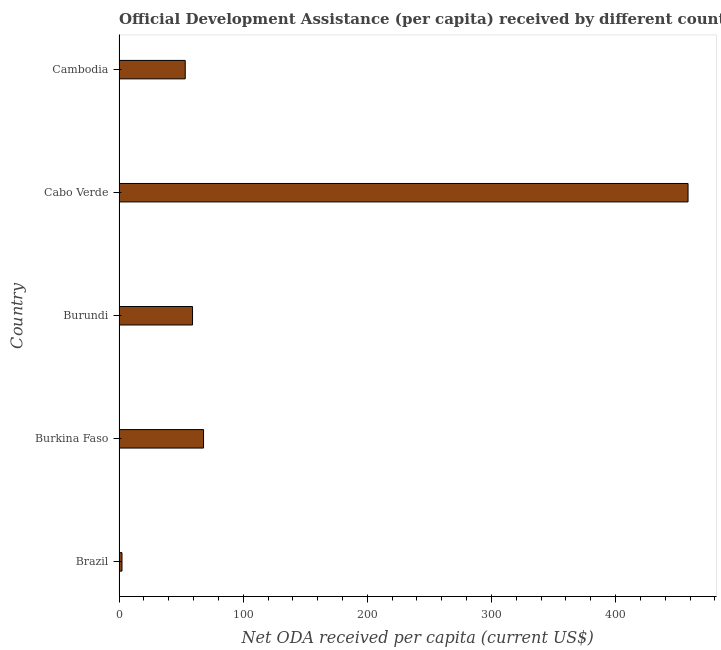What is the title of the graph?
Make the answer very short. Official Development Assistance (per capita) received by different countries in the year 2008. What is the label or title of the X-axis?
Offer a very short reply. Net ODA received per capita (current US$). What is the label or title of the Y-axis?
Ensure brevity in your answer.  Country. What is the net oda received per capita in Burkina Faso?
Your answer should be compact. 68.06. Across all countries, what is the maximum net oda received per capita?
Provide a succinct answer. 458.39. Across all countries, what is the minimum net oda received per capita?
Give a very brief answer. 2.36. In which country was the net oda received per capita maximum?
Your response must be concise. Cabo Verde. What is the sum of the net oda received per capita?
Ensure brevity in your answer.  641.33. What is the difference between the net oda received per capita in Brazil and Cambodia?
Your answer should be compact. -50.95. What is the average net oda received per capita per country?
Offer a very short reply. 128.27. What is the median net oda received per capita?
Provide a succinct answer. 59.2. In how many countries, is the net oda received per capita greater than 140 US$?
Offer a very short reply. 1. What is the ratio of the net oda received per capita in Brazil to that in Burundi?
Provide a succinct answer. 0.04. Is the net oda received per capita in Brazil less than that in Cabo Verde?
Give a very brief answer. Yes. What is the difference between the highest and the second highest net oda received per capita?
Provide a succinct answer. 390.32. Is the sum of the net oda received per capita in Burundi and Cabo Verde greater than the maximum net oda received per capita across all countries?
Keep it short and to the point. Yes. What is the difference between the highest and the lowest net oda received per capita?
Make the answer very short. 456.03. In how many countries, is the net oda received per capita greater than the average net oda received per capita taken over all countries?
Your response must be concise. 1. How many bars are there?
Your response must be concise. 5. How many countries are there in the graph?
Provide a succinct answer. 5. What is the Net ODA received per capita (current US$) of Brazil?
Make the answer very short. 2.36. What is the Net ODA received per capita (current US$) of Burkina Faso?
Your answer should be very brief. 68.06. What is the Net ODA received per capita (current US$) of Burundi?
Keep it short and to the point. 59.2. What is the Net ODA received per capita (current US$) of Cabo Verde?
Your answer should be very brief. 458.39. What is the Net ODA received per capita (current US$) of Cambodia?
Offer a terse response. 53.31. What is the difference between the Net ODA received per capita (current US$) in Brazil and Burkina Faso?
Provide a short and direct response. -65.7. What is the difference between the Net ODA received per capita (current US$) in Brazil and Burundi?
Your answer should be very brief. -56.84. What is the difference between the Net ODA received per capita (current US$) in Brazil and Cabo Verde?
Keep it short and to the point. -456.03. What is the difference between the Net ODA received per capita (current US$) in Brazil and Cambodia?
Offer a terse response. -50.95. What is the difference between the Net ODA received per capita (current US$) in Burkina Faso and Burundi?
Make the answer very short. 8.87. What is the difference between the Net ODA received per capita (current US$) in Burkina Faso and Cabo Verde?
Give a very brief answer. -390.33. What is the difference between the Net ODA received per capita (current US$) in Burkina Faso and Cambodia?
Offer a terse response. 14.75. What is the difference between the Net ODA received per capita (current US$) in Burundi and Cabo Verde?
Your answer should be very brief. -399.19. What is the difference between the Net ODA received per capita (current US$) in Burundi and Cambodia?
Make the answer very short. 5.89. What is the difference between the Net ODA received per capita (current US$) in Cabo Verde and Cambodia?
Ensure brevity in your answer.  405.08. What is the ratio of the Net ODA received per capita (current US$) in Brazil to that in Burkina Faso?
Keep it short and to the point. 0.04. What is the ratio of the Net ODA received per capita (current US$) in Brazil to that in Cabo Verde?
Your answer should be compact. 0.01. What is the ratio of the Net ODA received per capita (current US$) in Brazil to that in Cambodia?
Your answer should be very brief. 0.04. What is the ratio of the Net ODA received per capita (current US$) in Burkina Faso to that in Burundi?
Keep it short and to the point. 1.15. What is the ratio of the Net ODA received per capita (current US$) in Burkina Faso to that in Cabo Verde?
Keep it short and to the point. 0.15. What is the ratio of the Net ODA received per capita (current US$) in Burkina Faso to that in Cambodia?
Offer a terse response. 1.28. What is the ratio of the Net ODA received per capita (current US$) in Burundi to that in Cabo Verde?
Your answer should be very brief. 0.13. What is the ratio of the Net ODA received per capita (current US$) in Burundi to that in Cambodia?
Make the answer very short. 1.11. What is the ratio of the Net ODA received per capita (current US$) in Cabo Verde to that in Cambodia?
Your response must be concise. 8.6. 